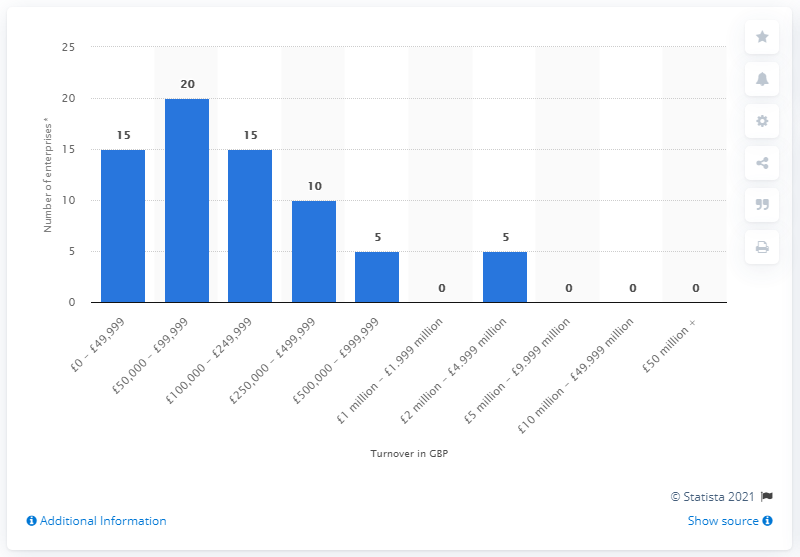Specify some key components in this picture. As of March 2020, it is estimated that there were approximately 5 enterprises in the UK with a turnover ranging from 500,000 to one million British pounds. 